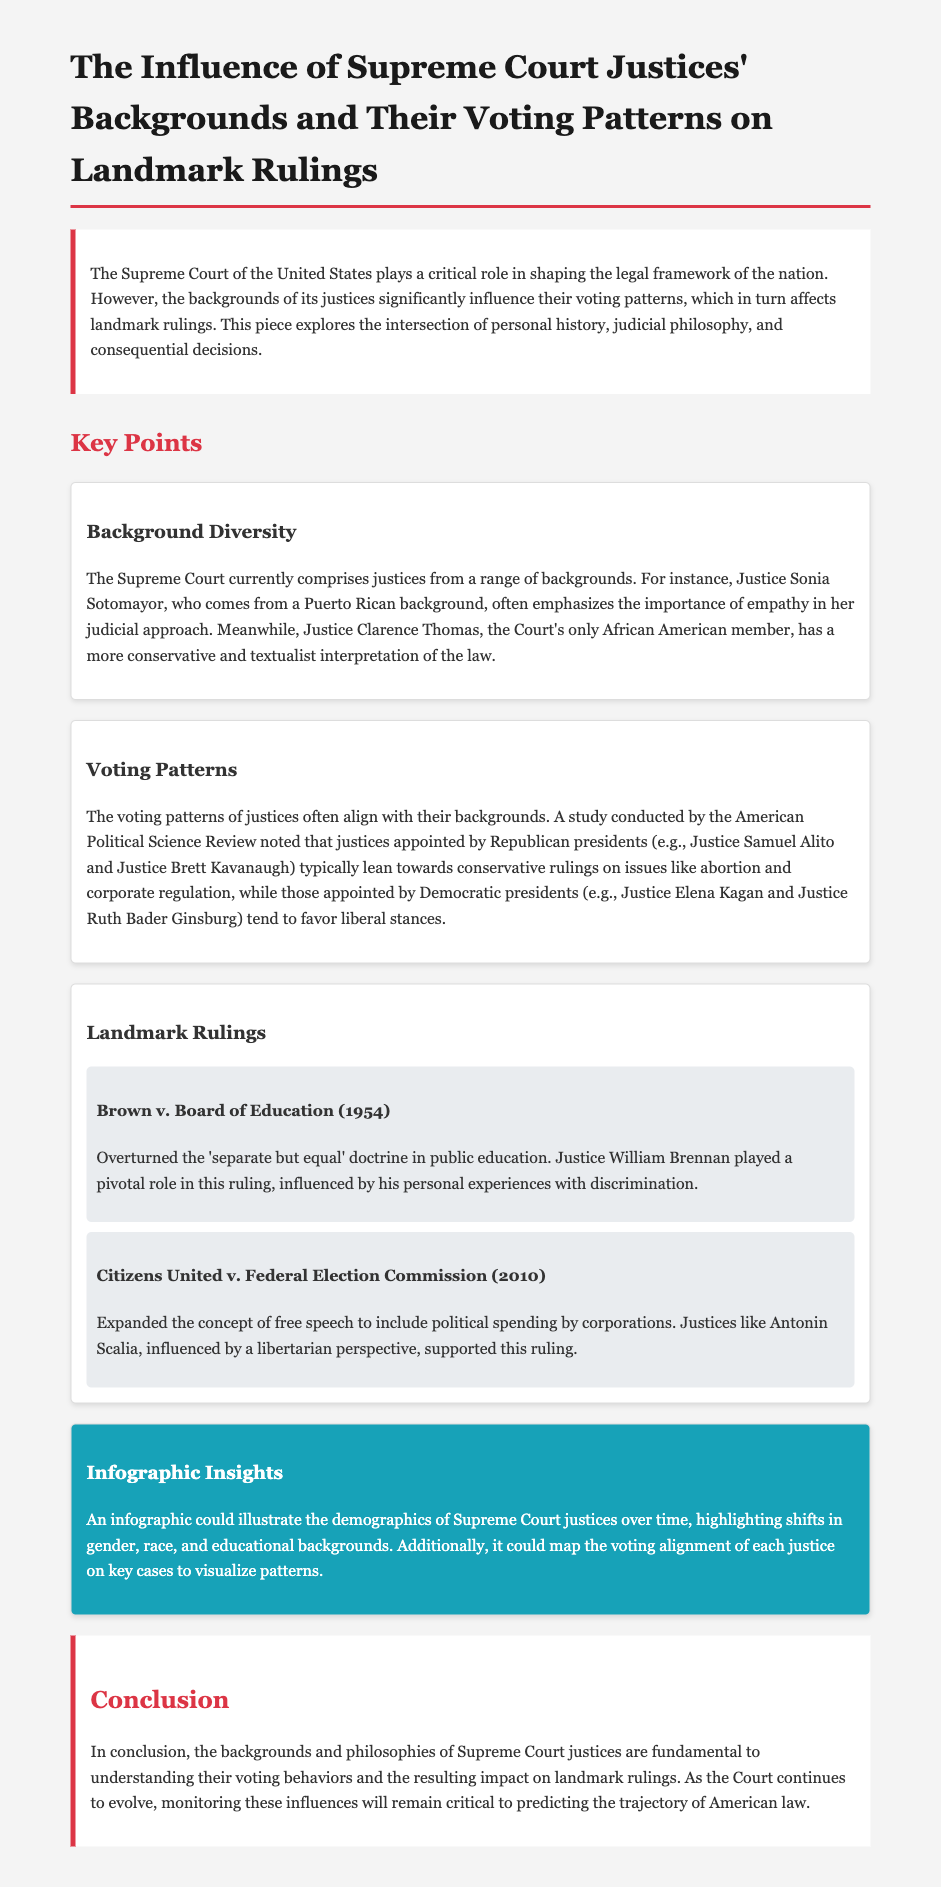What is the title of the document? The title is specified in the <title> tag of the HTML and is centered on the main topic discussed.
Answer: The Influence of Supreme Court Justices' Backgrounds and Their Voting Patterns on Landmark Rulings Who is the only African American member of the Supreme Court? The document mentions Justice Clarence Thomas specifically as the only African American justice currently serving on the Court.
Answer: Clarence Thomas What landmark case overturned the 'separate but equal' doctrine? The document states that Brown v. Board of Education (1954) is the case that overturned this doctrine.
Answer: Brown v. Board of Education Which justice played a pivotal role in Brown v. Board of Education? The document highlights Justice William Brennan as a key figure in the decision of this case.
Answer: William Brennan What year was Citizens United v. Federal Election Commission decided? The document provides the year in which the Citizens United case was ruled upon.
Answer: 2010 What concept was expanded in Citizens United v. Federal Election Commission? The document notes that the case expanded the concept of free speech regarding political spending by corporations.
Answer: Free speech Which justices typically lean towards conservative rulings? The document indicates that justices appointed by Republican presidents like Samuel Alito and Brett Kavanaugh tend to lean conservative.
Answer: Samuel Alito and Brett Kavanaugh What does the infographic mentioned illustrate? The document states that the infographic illustrates shifts in demographics of Supreme Court justices over time, including gender, race, and education.
Answer: Demographics of Supreme Court justices What is the conclusion about the backgrounds and philosophies of justices? The conclusion summarizes the importance of these factors in understanding justices' voting behaviors and their effects on landmark rulings.
Answer: Fundamental to understanding voting behaviors 